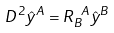<formula> <loc_0><loc_0><loc_500><loc_500>D ^ { 2 } \hat { y } ^ { A } = R _ { B } ^ { \text { \ } A } \hat { y } ^ { B }</formula> 